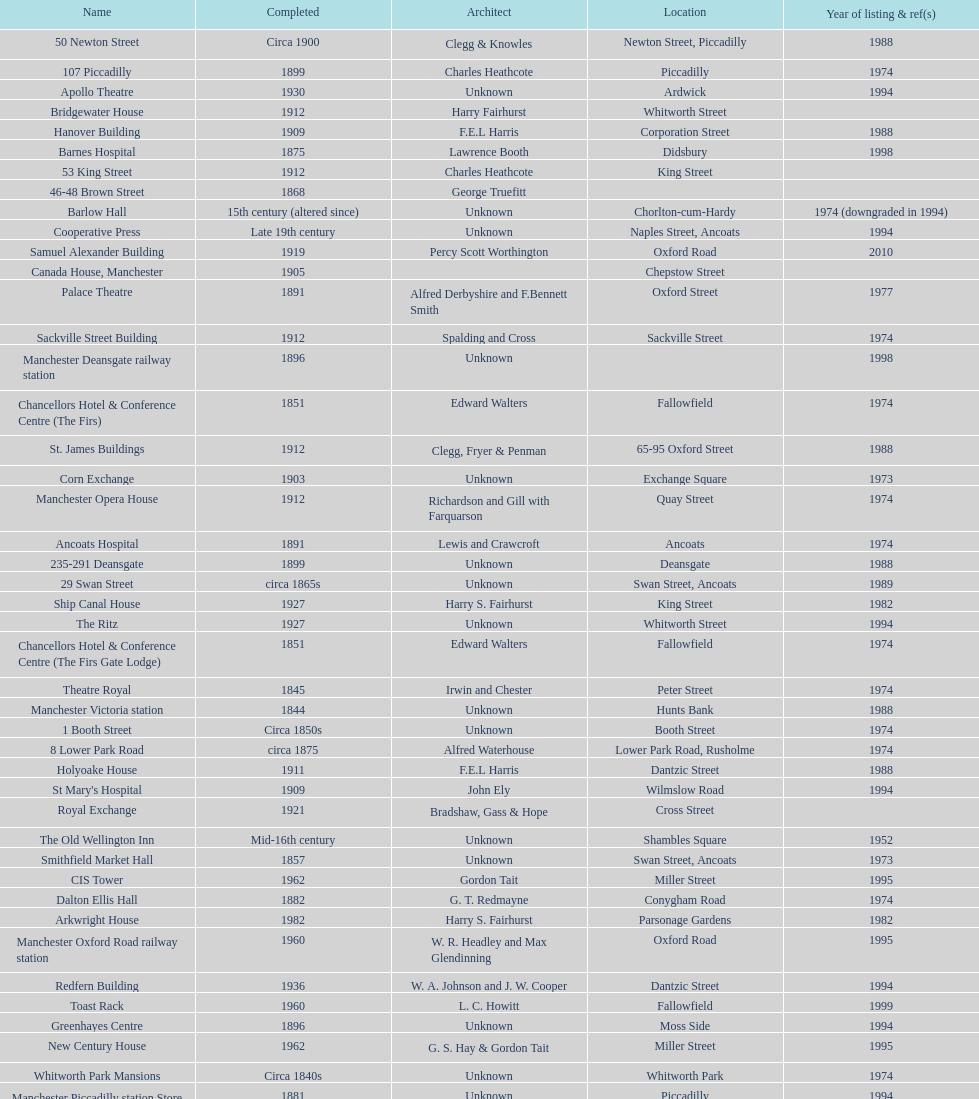Was charles heathcote the architect of ancoats hospital and apollo theatre? No. 